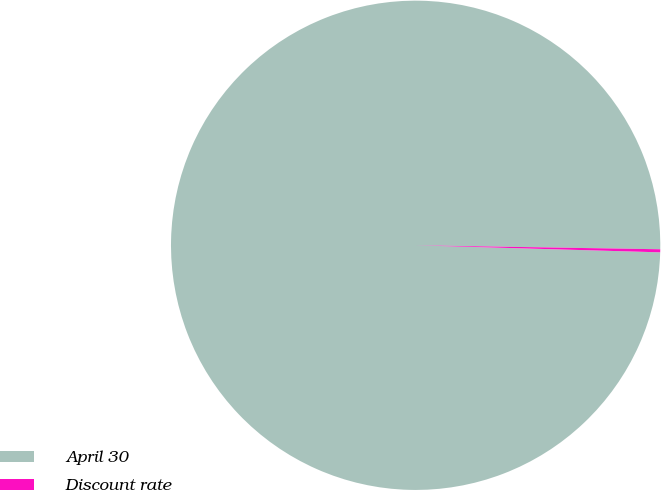<chart> <loc_0><loc_0><loc_500><loc_500><pie_chart><fcel>April 30<fcel>Discount rate<nl><fcel>99.8%<fcel>0.2%<nl></chart> 